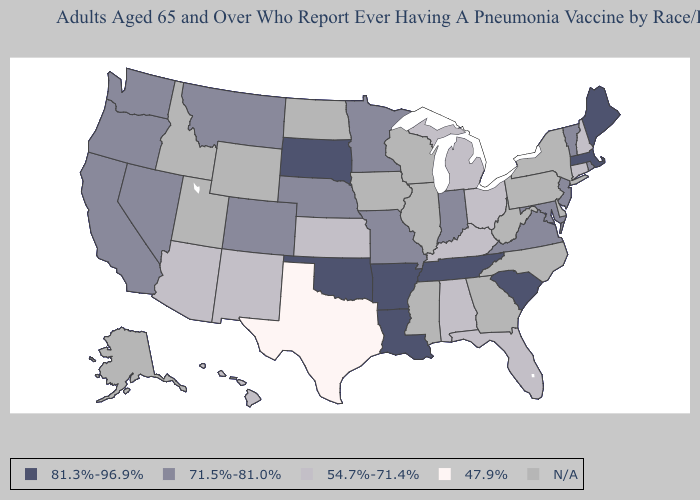Does Kentucky have the lowest value in the USA?
Write a very short answer. No. Does Maine have the highest value in the Northeast?
Write a very short answer. Yes. Does the map have missing data?
Answer briefly. Yes. Does Texas have the highest value in the USA?
Write a very short answer. No. What is the highest value in states that border Arizona?
Give a very brief answer. 71.5%-81.0%. What is the highest value in the South ?
Keep it brief. 81.3%-96.9%. Name the states that have a value in the range 54.7%-71.4%?
Keep it brief. Alabama, Arizona, Connecticut, Florida, Hawaii, Kansas, Kentucky, Michigan, New Hampshire, New Mexico, Ohio. What is the value of California?
Quick response, please. 71.5%-81.0%. Among the states that border Missouri , does Kentucky have the lowest value?
Write a very short answer. Yes. Does the map have missing data?
Quick response, please. Yes. What is the value of Ohio?
Keep it brief. 54.7%-71.4%. Does Ohio have the lowest value in the USA?
Answer briefly. No. Does Florida have the highest value in the South?
Answer briefly. No. 